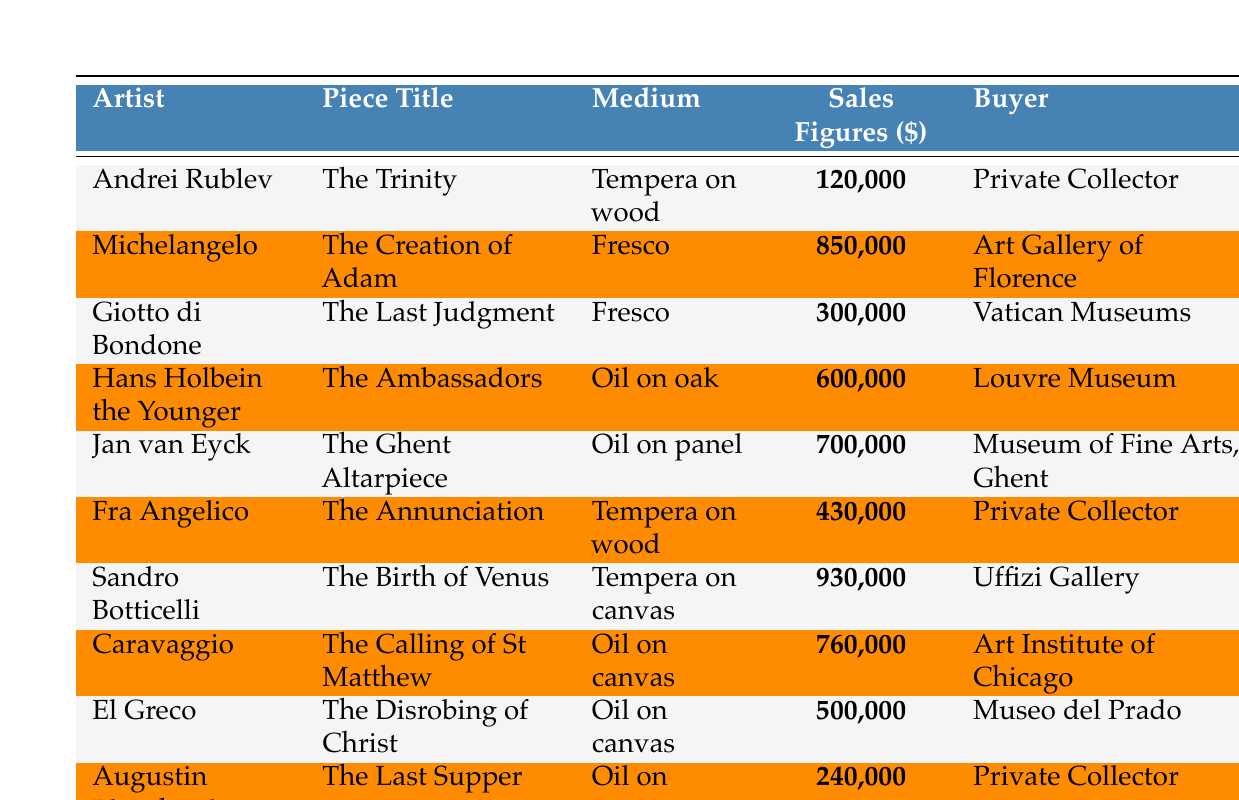What is the highest sale figure for a religious art piece in 2022? The table lists the sales figures for various religious art pieces. The highest sale figure is for "The Birth of Venus" by Sandro Botticelli, which is $930,000.
Answer: $930,000 Who bought "The Disrobing of Christ"? Referring to the table, "The Disrobing of Christ" was bought by Museo del Prado.
Answer: Museo del Prado How many pieces were sold for over $600,000 in 2022? Analyzing the table, three pieces have sales figures over $600,000: "The Birth of Venus" ($930,000), "The Creation of Adam" ($850,000), and "The Calling of St Matthew" ($760,000).
Answer: 3 What is the total sales figure for all pieces sold in 2022? I will sum all the sales figures listed: $120,000 + $850,000 + $300,000 + $600,000 + $700,000 + $430,000 + $930,000 + $760,000 + $500,000 + $240,000 = $4,160,000.
Answer: $4,160,000 Did any artist sell more than one religious art piece in 2022? Looking through the table, each artist mentioned has only one piece listed, so no artist sold more than one piece.
Answer: No What was the median sales figure of the religious art pieces sold in 2022? First, I will organize the sales figures in ascending order: $120,000, $240,000, $300,000, $430,000, $500,000, $600,000, $700,000, $760,000, $850,000, $930,000. As there are 10 data points, the median will be the average of the 5th and 6th figures: ($500,000 + $600,000) / 2 = $550,000.
Answer: $550,000 Which piece had the lowest sales figure and who was the buyer? The lowest sales figure is for "The Trinity" by Andrei Rublev at $120,000, bought by a Private Collector.
Answer: "The Trinity", Private Collector What is the difference in sales figures between the highest and lowest sold pieces? The highest sale figure is $930,000 for "The Birth of Venus", and the lowest is $120,000 for "The Trinity". The difference is $930,000 - $120,000 = $810,000.
Answer: $810,000 Which medium had the highest total sales in 2022? The total sales for each medium are as follows: Tempera on wood ($120,000 + $430,000), Fresco ($850,000 + $300,000), Oil on oak ($600,000), Oil on panel ($700,000), Tempera on canvas ($930,000), and Oil on canvas ($760,000 + $500,000 + $240,000). The highest total is for Oil on canvas at $2,500,000.
Answer: Oil on canvas How many different buyers were there for the religious art pieces sold in 2022? Counting the unique buyers in the table, there are 7 different buyers: Private Collector (2), Art Gallery of Florence, Vatican Museums, Louvre Museum, Museum of Fine Arts, Ghent, Uffizi Gallery, and Art Institute of Chicago. Therefore, there are 7 unique buyers.
Answer: 7 